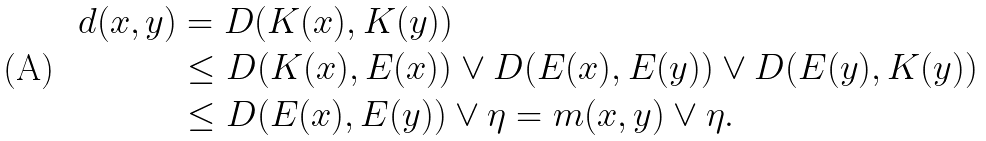<formula> <loc_0><loc_0><loc_500><loc_500>d ( x , y ) & = D ( K ( x ) , K ( y ) ) \\ & \leq D ( K ( x ) , E ( x ) ) \lor D ( E ( x ) , E ( y ) ) \lor D ( E ( y ) , K ( y ) ) \\ & \leq D ( E ( x ) , E ( y ) ) \lor \eta = m ( x , y ) \lor \eta .</formula> 